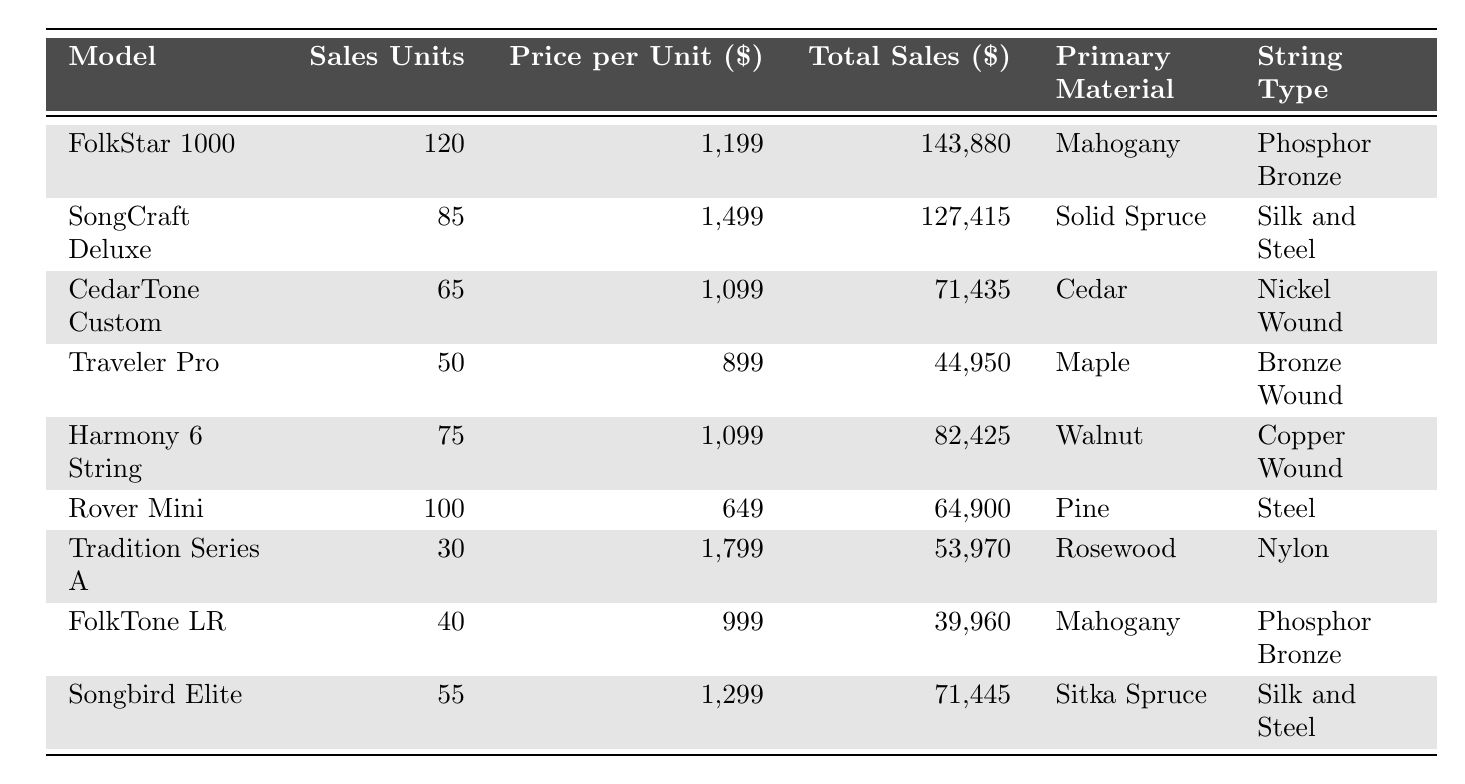What is the highest selling model in terms of units sold? Looking at the "Sales Units" column, the "FolkStar 1000" has the highest value of 120 units sold.
Answer: FolkStar 1000 How many units of the "Rover Mini" were sold? Referring to the "Sales Units" column, the "Rover Mini" has 100 units sold.
Answer: 100 What is the total sales amount for the "SongCraft Deluxe"? The "Total Sales" for "SongCraft Deluxe" is listed as $127,415.
Answer: $127,415 Which model uses "Phosphor Bronze" strings? Checking the "String Type" column, both "FolkStar 1000" and "FolkTone LR" use "Phosphor Bronze" strings.
Answer: FolkStar 1000, FolkTone LR What is the average price per unit of all the guitars listed? To find the average, sum all "Price per Unit" values: (1199 + 1499 + 1099 + 899 + 1099 + 649 + 1799 + 999 + 1299) = 10,440. There are 9 models, so the average price is 10,440 / 9 = 1,160.
Answer: $1,160 Is the "Tradition Series A" more expensive than the "CedarTone Custom"? Comparing the "Price per Unit," "Tradition Series A" has $1,799 while "CedarTone Custom" has $1,099. Since $1,799 is greater than $1,099, the statement is true.
Answer: Yes How much total revenue did "FolkTone LR" generate, and how does that compare to "Harmony 6 String"? The "Total Sales" for "FolkTone LR" is $39,960 and for "Harmony 6 String" is $82,425. Comparatively, $39,960 is less than $82,425, indicating that "Harmony 6 String" generated more revenue.
Answer: Less What is the combined total sales of all guitars made from Mahogany? The total sales for "FolkStar 1000" and "FolkTone LR" are $143,880 and $39,960 respectively. Adding these gives $143,880 + $39,960 = $183,840.
Answer: $183,840 Which model sold the least number of units, and how many were sold? The "Tradition Series A" sold the least units at 30.
Answer: Tradition Series A, 30 If we sum the sales units of models made with "Rosewood" and "Cedar", how many units do we get? "Tradition Series A" (Rosewood) sold 30 units and "CedarTone Custom" (Cedar) sold 65 units. Adding them gives 30 + 65 = 95 units.
Answer: 95 What string type is most frequently associated with high-selling models? By analyzing the models with the highest total sales, "FolkStar 1000" and "SongCraft Deluxe" have different string types. "FolkStar 1000" uses "Phosphor Bronze," while "SongCraft Deluxe" uses "Silk and Steel." However, since "FolkStar 1000" has the highest sales, "Phosphor Bronze" can be seen as more frequently associated with high sales.
Answer: Phosphor Bronze 